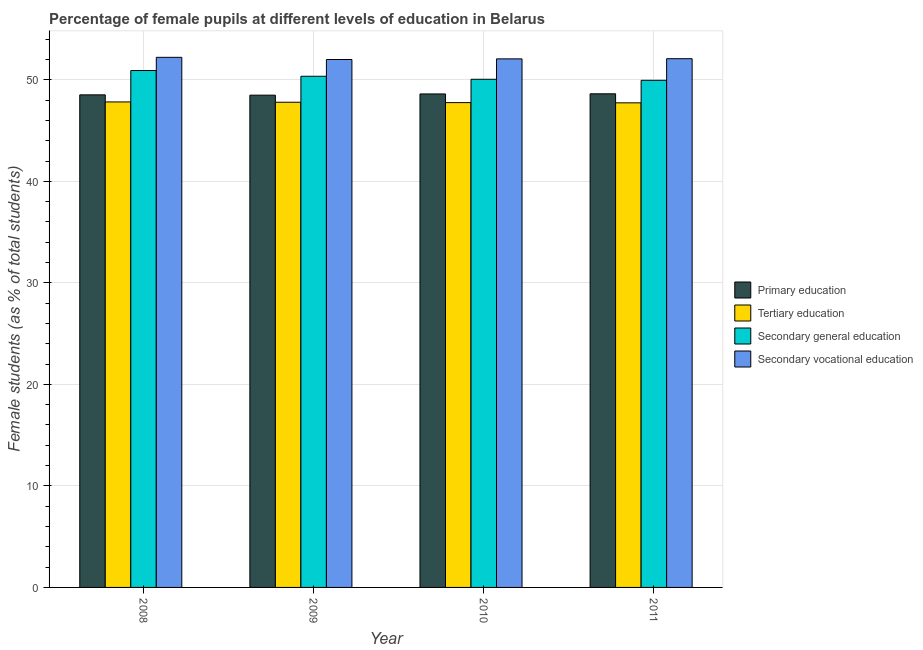How many groups of bars are there?
Offer a very short reply. 4. Are the number of bars on each tick of the X-axis equal?
Give a very brief answer. Yes. What is the percentage of female students in primary education in 2011?
Keep it short and to the point. 48.62. Across all years, what is the maximum percentage of female students in tertiary education?
Your answer should be compact. 47.82. Across all years, what is the minimum percentage of female students in primary education?
Offer a very short reply. 48.49. What is the total percentage of female students in secondary education in the graph?
Provide a succinct answer. 201.27. What is the difference between the percentage of female students in primary education in 2008 and that in 2010?
Your answer should be compact. -0.09. What is the difference between the percentage of female students in primary education in 2008 and the percentage of female students in secondary vocational education in 2011?
Make the answer very short. -0.1. What is the average percentage of female students in primary education per year?
Keep it short and to the point. 48.56. In the year 2009, what is the difference between the percentage of female students in primary education and percentage of female students in secondary vocational education?
Ensure brevity in your answer.  0. What is the ratio of the percentage of female students in secondary vocational education in 2010 to that in 2011?
Make the answer very short. 1. What is the difference between the highest and the second highest percentage of female students in primary education?
Give a very brief answer. 0.01. What is the difference between the highest and the lowest percentage of female students in tertiary education?
Offer a terse response. 0.09. In how many years, is the percentage of female students in secondary education greater than the average percentage of female students in secondary education taken over all years?
Make the answer very short. 2. Is the sum of the percentage of female students in secondary vocational education in 2008 and 2011 greater than the maximum percentage of female students in primary education across all years?
Your answer should be compact. Yes. Is it the case that in every year, the sum of the percentage of female students in secondary education and percentage of female students in primary education is greater than the sum of percentage of female students in tertiary education and percentage of female students in secondary vocational education?
Give a very brief answer. No. What does the 2nd bar from the left in 2010 represents?
Keep it short and to the point. Tertiary education. What does the 2nd bar from the right in 2009 represents?
Give a very brief answer. Secondary general education. Is it the case that in every year, the sum of the percentage of female students in primary education and percentage of female students in tertiary education is greater than the percentage of female students in secondary education?
Keep it short and to the point. Yes. How many bars are there?
Your answer should be compact. 16. How many years are there in the graph?
Make the answer very short. 4. Where does the legend appear in the graph?
Provide a succinct answer. Center right. How are the legend labels stacked?
Provide a short and direct response. Vertical. What is the title of the graph?
Your response must be concise. Percentage of female pupils at different levels of education in Belarus. Does "Industry" appear as one of the legend labels in the graph?
Your answer should be compact. No. What is the label or title of the X-axis?
Your answer should be compact. Year. What is the label or title of the Y-axis?
Your response must be concise. Female students (as % of total students). What is the Female students (as % of total students) of Primary education in 2008?
Give a very brief answer. 48.52. What is the Female students (as % of total students) in Tertiary education in 2008?
Give a very brief answer. 47.82. What is the Female students (as % of total students) in Secondary general education in 2008?
Offer a very short reply. 50.92. What is the Female students (as % of total students) in Secondary vocational education in 2008?
Your answer should be compact. 52.22. What is the Female students (as % of total students) in Primary education in 2009?
Your answer should be very brief. 48.49. What is the Female students (as % of total students) in Tertiary education in 2009?
Keep it short and to the point. 47.79. What is the Female students (as % of total students) of Secondary general education in 2009?
Your answer should be compact. 50.35. What is the Female students (as % of total students) in Secondary vocational education in 2009?
Keep it short and to the point. 52. What is the Female students (as % of total students) in Primary education in 2010?
Give a very brief answer. 48.61. What is the Female students (as % of total students) in Tertiary education in 2010?
Give a very brief answer. 47.75. What is the Female students (as % of total students) in Secondary general education in 2010?
Make the answer very short. 50.05. What is the Female students (as % of total students) in Secondary vocational education in 2010?
Your answer should be compact. 52.06. What is the Female students (as % of total students) in Primary education in 2011?
Your response must be concise. 48.62. What is the Female students (as % of total students) in Tertiary education in 2011?
Provide a succinct answer. 47.73. What is the Female students (as % of total students) of Secondary general education in 2011?
Make the answer very short. 49.95. What is the Female students (as % of total students) in Secondary vocational education in 2011?
Give a very brief answer. 52.08. Across all years, what is the maximum Female students (as % of total students) in Primary education?
Provide a succinct answer. 48.62. Across all years, what is the maximum Female students (as % of total students) of Tertiary education?
Offer a very short reply. 47.82. Across all years, what is the maximum Female students (as % of total students) in Secondary general education?
Provide a short and direct response. 50.92. Across all years, what is the maximum Female students (as % of total students) in Secondary vocational education?
Your answer should be very brief. 52.22. Across all years, what is the minimum Female students (as % of total students) in Primary education?
Make the answer very short. 48.49. Across all years, what is the minimum Female students (as % of total students) in Tertiary education?
Offer a terse response. 47.73. Across all years, what is the minimum Female students (as % of total students) of Secondary general education?
Give a very brief answer. 49.95. Across all years, what is the minimum Female students (as % of total students) of Secondary vocational education?
Give a very brief answer. 52. What is the total Female students (as % of total students) of Primary education in the graph?
Provide a short and direct response. 194.24. What is the total Female students (as % of total students) in Tertiary education in the graph?
Offer a terse response. 191.1. What is the total Female students (as % of total students) in Secondary general education in the graph?
Offer a terse response. 201.27. What is the total Female students (as % of total students) in Secondary vocational education in the graph?
Keep it short and to the point. 208.36. What is the difference between the Female students (as % of total students) of Primary education in 2008 and that in 2009?
Make the answer very short. 0.03. What is the difference between the Female students (as % of total students) in Tertiary education in 2008 and that in 2009?
Offer a terse response. 0.03. What is the difference between the Female students (as % of total students) of Secondary general education in 2008 and that in 2009?
Your response must be concise. 0.57. What is the difference between the Female students (as % of total students) of Secondary vocational education in 2008 and that in 2009?
Keep it short and to the point. 0.21. What is the difference between the Female students (as % of total students) in Primary education in 2008 and that in 2010?
Keep it short and to the point. -0.09. What is the difference between the Female students (as % of total students) in Tertiary education in 2008 and that in 2010?
Ensure brevity in your answer.  0.07. What is the difference between the Female students (as % of total students) of Secondary general education in 2008 and that in 2010?
Offer a very short reply. 0.86. What is the difference between the Female students (as % of total students) in Secondary vocational education in 2008 and that in 2010?
Your answer should be compact. 0.15. What is the difference between the Female students (as % of total students) in Primary education in 2008 and that in 2011?
Provide a short and direct response. -0.1. What is the difference between the Female students (as % of total students) in Tertiary education in 2008 and that in 2011?
Provide a succinct answer. 0.09. What is the difference between the Female students (as % of total students) in Secondary general education in 2008 and that in 2011?
Ensure brevity in your answer.  0.96. What is the difference between the Female students (as % of total students) in Secondary vocational education in 2008 and that in 2011?
Provide a short and direct response. 0.14. What is the difference between the Female students (as % of total students) in Primary education in 2009 and that in 2010?
Provide a succinct answer. -0.12. What is the difference between the Female students (as % of total students) of Tertiary education in 2009 and that in 2010?
Your answer should be compact. 0.04. What is the difference between the Female students (as % of total students) in Secondary general education in 2009 and that in 2010?
Keep it short and to the point. 0.3. What is the difference between the Female students (as % of total students) of Secondary vocational education in 2009 and that in 2010?
Keep it short and to the point. -0.06. What is the difference between the Female students (as % of total students) in Primary education in 2009 and that in 2011?
Give a very brief answer. -0.13. What is the difference between the Female students (as % of total students) in Tertiary education in 2009 and that in 2011?
Keep it short and to the point. 0.06. What is the difference between the Female students (as % of total students) in Secondary general education in 2009 and that in 2011?
Give a very brief answer. 0.4. What is the difference between the Female students (as % of total students) in Secondary vocational education in 2009 and that in 2011?
Keep it short and to the point. -0.08. What is the difference between the Female students (as % of total students) in Primary education in 2010 and that in 2011?
Provide a succinct answer. -0.01. What is the difference between the Female students (as % of total students) in Tertiary education in 2010 and that in 2011?
Your response must be concise. 0.02. What is the difference between the Female students (as % of total students) in Secondary general education in 2010 and that in 2011?
Offer a terse response. 0.1. What is the difference between the Female students (as % of total students) of Secondary vocational education in 2010 and that in 2011?
Keep it short and to the point. -0.02. What is the difference between the Female students (as % of total students) of Primary education in 2008 and the Female students (as % of total students) of Tertiary education in 2009?
Make the answer very short. 0.73. What is the difference between the Female students (as % of total students) of Primary education in 2008 and the Female students (as % of total students) of Secondary general education in 2009?
Keep it short and to the point. -1.83. What is the difference between the Female students (as % of total students) in Primary education in 2008 and the Female students (as % of total students) in Secondary vocational education in 2009?
Offer a very short reply. -3.48. What is the difference between the Female students (as % of total students) in Tertiary education in 2008 and the Female students (as % of total students) in Secondary general education in 2009?
Offer a very short reply. -2.53. What is the difference between the Female students (as % of total students) of Tertiary education in 2008 and the Female students (as % of total students) of Secondary vocational education in 2009?
Make the answer very short. -4.18. What is the difference between the Female students (as % of total students) of Secondary general education in 2008 and the Female students (as % of total students) of Secondary vocational education in 2009?
Ensure brevity in your answer.  -1.09. What is the difference between the Female students (as % of total students) of Primary education in 2008 and the Female students (as % of total students) of Tertiary education in 2010?
Your response must be concise. 0.76. What is the difference between the Female students (as % of total students) of Primary education in 2008 and the Female students (as % of total students) of Secondary general education in 2010?
Offer a terse response. -1.53. What is the difference between the Female students (as % of total students) in Primary education in 2008 and the Female students (as % of total students) in Secondary vocational education in 2010?
Offer a terse response. -3.54. What is the difference between the Female students (as % of total students) of Tertiary education in 2008 and the Female students (as % of total students) of Secondary general education in 2010?
Your answer should be very brief. -2.23. What is the difference between the Female students (as % of total students) of Tertiary education in 2008 and the Female students (as % of total students) of Secondary vocational education in 2010?
Offer a terse response. -4.24. What is the difference between the Female students (as % of total students) in Secondary general education in 2008 and the Female students (as % of total students) in Secondary vocational education in 2010?
Keep it short and to the point. -1.15. What is the difference between the Female students (as % of total students) of Primary education in 2008 and the Female students (as % of total students) of Tertiary education in 2011?
Your answer should be compact. 0.79. What is the difference between the Female students (as % of total students) of Primary education in 2008 and the Female students (as % of total students) of Secondary general education in 2011?
Ensure brevity in your answer.  -1.43. What is the difference between the Female students (as % of total students) in Primary education in 2008 and the Female students (as % of total students) in Secondary vocational education in 2011?
Offer a very short reply. -3.56. What is the difference between the Female students (as % of total students) in Tertiary education in 2008 and the Female students (as % of total students) in Secondary general education in 2011?
Offer a terse response. -2.13. What is the difference between the Female students (as % of total students) in Tertiary education in 2008 and the Female students (as % of total students) in Secondary vocational education in 2011?
Provide a short and direct response. -4.26. What is the difference between the Female students (as % of total students) of Secondary general education in 2008 and the Female students (as % of total students) of Secondary vocational education in 2011?
Your answer should be very brief. -1.16. What is the difference between the Female students (as % of total students) in Primary education in 2009 and the Female students (as % of total students) in Tertiary education in 2010?
Keep it short and to the point. 0.74. What is the difference between the Female students (as % of total students) of Primary education in 2009 and the Female students (as % of total students) of Secondary general education in 2010?
Make the answer very short. -1.56. What is the difference between the Female students (as % of total students) of Primary education in 2009 and the Female students (as % of total students) of Secondary vocational education in 2010?
Give a very brief answer. -3.57. What is the difference between the Female students (as % of total students) of Tertiary education in 2009 and the Female students (as % of total students) of Secondary general education in 2010?
Your response must be concise. -2.26. What is the difference between the Female students (as % of total students) of Tertiary education in 2009 and the Female students (as % of total students) of Secondary vocational education in 2010?
Your response must be concise. -4.27. What is the difference between the Female students (as % of total students) of Secondary general education in 2009 and the Female students (as % of total students) of Secondary vocational education in 2010?
Your response must be concise. -1.71. What is the difference between the Female students (as % of total students) of Primary education in 2009 and the Female students (as % of total students) of Tertiary education in 2011?
Provide a succinct answer. 0.76. What is the difference between the Female students (as % of total students) of Primary education in 2009 and the Female students (as % of total students) of Secondary general education in 2011?
Keep it short and to the point. -1.46. What is the difference between the Female students (as % of total students) in Primary education in 2009 and the Female students (as % of total students) in Secondary vocational education in 2011?
Keep it short and to the point. -3.59. What is the difference between the Female students (as % of total students) of Tertiary education in 2009 and the Female students (as % of total students) of Secondary general education in 2011?
Keep it short and to the point. -2.16. What is the difference between the Female students (as % of total students) of Tertiary education in 2009 and the Female students (as % of total students) of Secondary vocational education in 2011?
Offer a very short reply. -4.29. What is the difference between the Female students (as % of total students) in Secondary general education in 2009 and the Female students (as % of total students) in Secondary vocational education in 2011?
Give a very brief answer. -1.73. What is the difference between the Female students (as % of total students) of Primary education in 2010 and the Female students (as % of total students) of Tertiary education in 2011?
Offer a very short reply. 0.88. What is the difference between the Female students (as % of total students) in Primary education in 2010 and the Female students (as % of total students) in Secondary general education in 2011?
Offer a terse response. -1.34. What is the difference between the Female students (as % of total students) of Primary education in 2010 and the Female students (as % of total students) of Secondary vocational education in 2011?
Give a very brief answer. -3.47. What is the difference between the Female students (as % of total students) in Tertiary education in 2010 and the Female students (as % of total students) in Secondary general education in 2011?
Provide a succinct answer. -2.2. What is the difference between the Female students (as % of total students) of Tertiary education in 2010 and the Female students (as % of total students) of Secondary vocational education in 2011?
Provide a short and direct response. -4.33. What is the difference between the Female students (as % of total students) of Secondary general education in 2010 and the Female students (as % of total students) of Secondary vocational education in 2011?
Your answer should be compact. -2.03. What is the average Female students (as % of total students) of Primary education per year?
Ensure brevity in your answer.  48.56. What is the average Female students (as % of total students) in Tertiary education per year?
Offer a very short reply. 47.78. What is the average Female students (as % of total students) in Secondary general education per year?
Give a very brief answer. 50.32. What is the average Female students (as % of total students) of Secondary vocational education per year?
Provide a succinct answer. 52.09. In the year 2008, what is the difference between the Female students (as % of total students) in Primary education and Female students (as % of total students) in Tertiary education?
Your response must be concise. 0.7. In the year 2008, what is the difference between the Female students (as % of total students) in Primary education and Female students (as % of total students) in Secondary general education?
Your response must be concise. -2.4. In the year 2008, what is the difference between the Female students (as % of total students) in Primary education and Female students (as % of total students) in Secondary vocational education?
Your answer should be compact. -3.7. In the year 2008, what is the difference between the Female students (as % of total students) in Tertiary education and Female students (as % of total students) in Secondary general education?
Give a very brief answer. -3.09. In the year 2008, what is the difference between the Female students (as % of total students) in Tertiary education and Female students (as % of total students) in Secondary vocational education?
Ensure brevity in your answer.  -4.39. In the year 2008, what is the difference between the Female students (as % of total students) in Secondary general education and Female students (as % of total students) in Secondary vocational education?
Your response must be concise. -1.3. In the year 2009, what is the difference between the Female students (as % of total students) in Primary education and Female students (as % of total students) in Tertiary education?
Offer a terse response. 0.7. In the year 2009, what is the difference between the Female students (as % of total students) of Primary education and Female students (as % of total students) of Secondary general education?
Provide a short and direct response. -1.86. In the year 2009, what is the difference between the Female students (as % of total students) of Primary education and Female students (as % of total students) of Secondary vocational education?
Offer a very short reply. -3.51. In the year 2009, what is the difference between the Female students (as % of total students) in Tertiary education and Female students (as % of total students) in Secondary general education?
Offer a very short reply. -2.56. In the year 2009, what is the difference between the Female students (as % of total students) in Tertiary education and Female students (as % of total students) in Secondary vocational education?
Provide a succinct answer. -4.21. In the year 2009, what is the difference between the Female students (as % of total students) in Secondary general education and Female students (as % of total students) in Secondary vocational education?
Your response must be concise. -1.65. In the year 2010, what is the difference between the Female students (as % of total students) in Primary education and Female students (as % of total students) in Tertiary education?
Ensure brevity in your answer.  0.85. In the year 2010, what is the difference between the Female students (as % of total students) in Primary education and Female students (as % of total students) in Secondary general education?
Offer a very short reply. -1.44. In the year 2010, what is the difference between the Female students (as % of total students) in Primary education and Female students (as % of total students) in Secondary vocational education?
Provide a short and direct response. -3.45. In the year 2010, what is the difference between the Female students (as % of total students) in Tertiary education and Female students (as % of total students) in Secondary general education?
Your answer should be compact. -2.3. In the year 2010, what is the difference between the Female students (as % of total students) in Tertiary education and Female students (as % of total students) in Secondary vocational education?
Provide a succinct answer. -4.31. In the year 2010, what is the difference between the Female students (as % of total students) in Secondary general education and Female students (as % of total students) in Secondary vocational education?
Offer a very short reply. -2.01. In the year 2011, what is the difference between the Female students (as % of total students) of Primary education and Female students (as % of total students) of Tertiary education?
Keep it short and to the point. 0.89. In the year 2011, what is the difference between the Female students (as % of total students) in Primary education and Female students (as % of total students) in Secondary general education?
Your response must be concise. -1.33. In the year 2011, what is the difference between the Female students (as % of total students) in Primary education and Female students (as % of total students) in Secondary vocational education?
Give a very brief answer. -3.46. In the year 2011, what is the difference between the Female students (as % of total students) of Tertiary education and Female students (as % of total students) of Secondary general education?
Offer a terse response. -2.22. In the year 2011, what is the difference between the Female students (as % of total students) in Tertiary education and Female students (as % of total students) in Secondary vocational education?
Your response must be concise. -4.35. In the year 2011, what is the difference between the Female students (as % of total students) in Secondary general education and Female students (as % of total students) in Secondary vocational education?
Your response must be concise. -2.13. What is the ratio of the Female students (as % of total students) in Secondary general education in 2008 to that in 2009?
Give a very brief answer. 1.01. What is the ratio of the Female students (as % of total students) in Secondary vocational education in 2008 to that in 2009?
Your answer should be compact. 1. What is the ratio of the Female students (as % of total students) of Primary education in 2008 to that in 2010?
Make the answer very short. 1. What is the ratio of the Female students (as % of total students) of Tertiary education in 2008 to that in 2010?
Keep it short and to the point. 1. What is the ratio of the Female students (as % of total students) of Secondary general education in 2008 to that in 2010?
Your answer should be very brief. 1.02. What is the ratio of the Female students (as % of total students) in Secondary vocational education in 2008 to that in 2010?
Keep it short and to the point. 1. What is the ratio of the Female students (as % of total students) of Primary education in 2008 to that in 2011?
Your answer should be very brief. 1. What is the ratio of the Female students (as % of total students) of Tertiary education in 2008 to that in 2011?
Provide a short and direct response. 1. What is the ratio of the Female students (as % of total students) in Secondary general education in 2008 to that in 2011?
Your response must be concise. 1.02. What is the ratio of the Female students (as % of total students) of Primary education in 2009 to that in 2010?
Your response must be concise. 1. What is the ratio of the Female students (as % of total students) in Secondary general education in 2009 to that in 2010?
Offer a terse response. 1.01. What is the ratio of the Female students (as % of total students) in Secondary vocational education in 2009 to that in 2010?
Your answer should be very brief. 1. What is the ratio of the Female students (as % of total students) of Secondary general education in 2009 to that in 2011?
Your answer should be compact. 1.01. What is the ratio of the Female students (as % of total students) in Secondary vocational education in 2009 to that in 2011?
Give a very brief answer. 1. What is the ratio of the Female students (as % of total students) in Primary education in 2010 to that in 2011?
Your response must be concise. 1. What is the ratio of the Female students (as % of total students) in Secondary vocational education in 2010 to that in 2011?
Give a very brief answer. 1. What is the difference between the highest and the second highest Female students (as % of total students) of Primary education?
Provide a succinct answer. 0.01. What is the difference between the highest and the second highest Female students (as % of total students) in Tertiary education?
Make the answer very short. 0.03. What is the difference between the highest and the second highest Female students (as % of total students) in Secondary general education?
Offer a very short reply. 0.57. What is the difference between the highest and the second highest Female students (as % of total students) of Secondary vocational education?
Keep it short and to the point. 0.14. What is the difference between the highest and the lowest Female students (as % of total students) of Primary education?
Give a very brief answer. 0.13. What is the difference between the highest and the lowest Female students (as % of total students) of Tertiary education?
Offer a terse response. 0.09. What is the difference between the highest and the lowest Female students (as % of total students) of Secondary vocational education?
Make the answer very short. 0.21. 